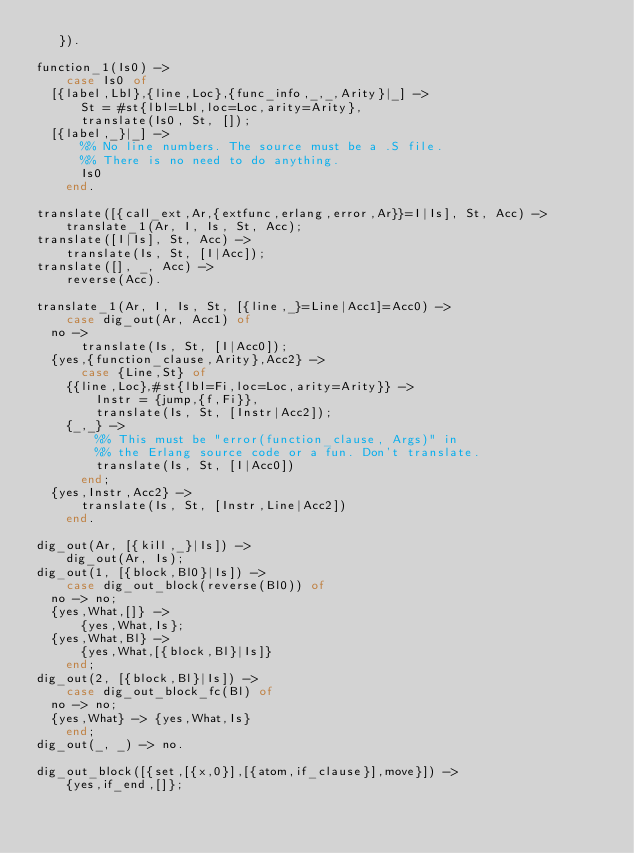<code> <loc_0><loc_0><loc_500><loc_500><_Erlang_>	 }).

function_1(Is0) ->
    case Is0 of
	[{label,Lbl},{line,Loc},{func_info,_,_,Arity}|_] ->
	    St = #st{lbl=Lbl,loc=Loc,arity=Arity},
	    translate(Is0, St, []);
	[{label,_}|_] ->
	    %% No line numbers. The source must be a .S file.
	    %% There is no need to do anything.
	    Is0
    end.

translate([{call_ext,Ar,{extfunc,erlang,error,Ar}}=I|Is], St, Acc) ->
    translate_1(Ar, I, Is, St, Acc);
translate([I|Is], St, Acc) ->
    translate(Is, St, [I|Acc]);
translate([], _, Acc) ->
    reverse(Acc).

translate_1(Ar, I, Is, St, [{line,_}=Line|Acc1]=Acc0) ->
    case dig_out(Ar, Acc1) of
	no ->
	    translate(Is, St, [I|Acc0]);
	{yes,{function_clause,Arity},Acc2} ->
	    case {Line,St} of
		{{line,Loc},#st{lbl=Fi,loc=Loc,arity=Arity}} ->
		    Instr = {jump,{f,Fi}},
		    translate(Is, St, [Instr|Acc2]);
		{_,_} ->
		    %% This must be "error(function_clause, Args)" in
		    %% the Erlang source code or a fun. Don't translate.
		    translate(Is, St, [I|Acc0])
	    end;
	{yes,Instr,Acc2} ->
	    translate(Is, St, [Instr,Line|Acc2])
    end.

dig_out(Ar, [{kill,_}|Is]) ->
    dig_out(Ar, Is);
dig_out(1, [{block,Bl0}|Is]) ->
    case dig_out_block(reverse(Bl0)) of
	no -> no;
	{yes,What,[]} ->
	    {yes,What,Is};
	{yes,What,Bl} ->
	    {yes,What,[{block,Bl}|Is]}
    end;
dig_out(2, [{block,Bl}|Is]) ->
    case dig_out_block_fc(Bl) of
	no -> no;
	{yes,What} -> {yes,What,Is}
    end;
dig_out(_, _) -> no.

dig_out_block([{set,[{x,0}],[{atom,if_clause}],move}]) ->
    {yes,if_end,[]};</code> 